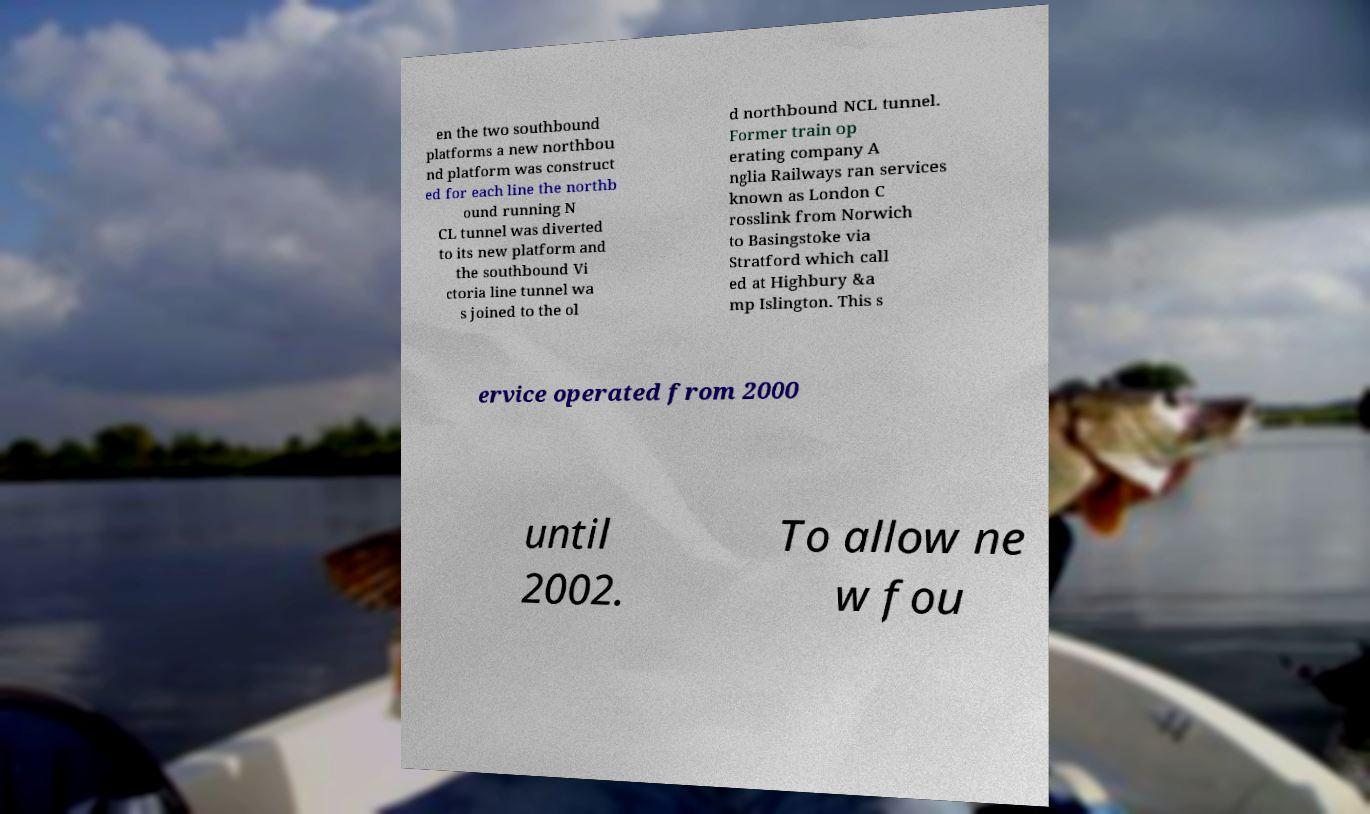For documentation purposes, I need the text within this image transcribed. Could you provide that? en the two southbound platforms a new northbou nd platform was construct ed for each line the northb ound running N CL tunnel was diverted to its new platform and the southbound Vi ctoria line tunnel wa s joined to the ol d northbound NCL tunnel. Former train op erating company A nglia Railways ran services known as London C rosslink from Norwich to Basingstoke via Stratford which call ed at Highbury &a mp Islington. This s ervice operated from 2000 until 2002. To allow ne w fou 